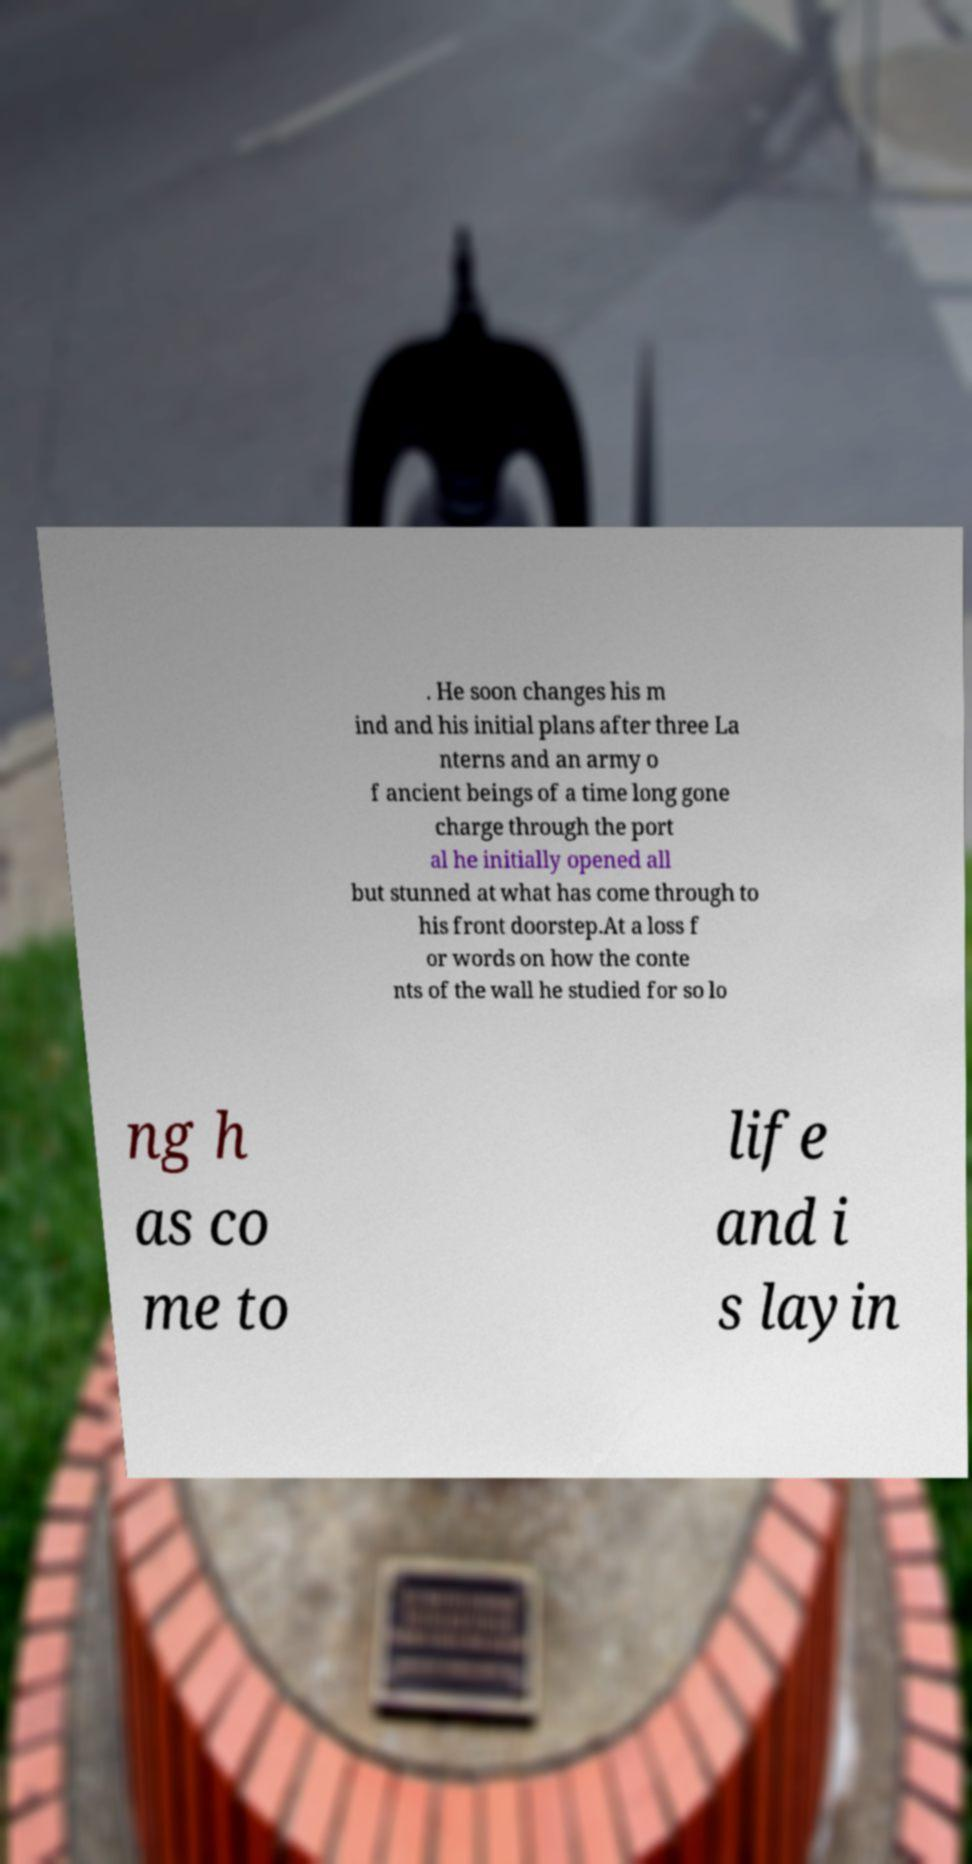Please identify and transcribe the text found in this image. . He soon changes his m ind and his initial plans after three La nterns and an army o f ancient beings of a time long gone charge through the port al he initially opened all but stunned at what has come through to his front doorstep.At a loss f or words on how the conte nts of the wall he studied for so lo ng h as co me to life and i s layin 